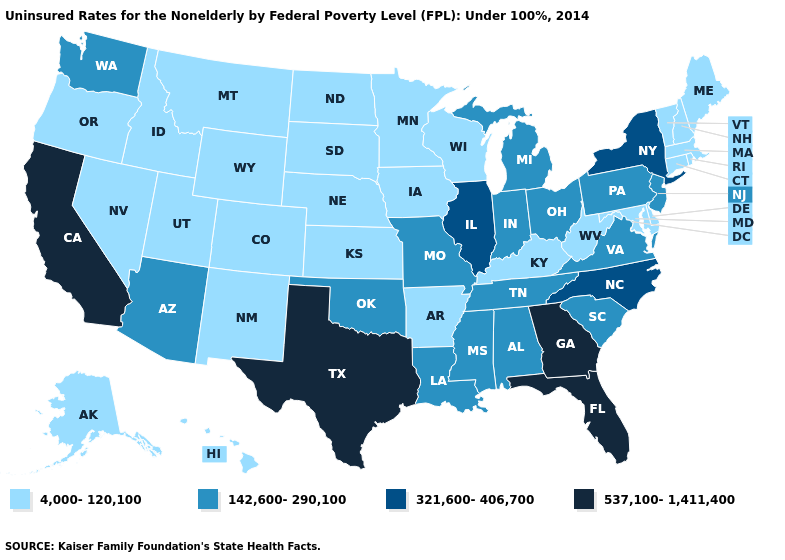Does New Hampshire have the lowest value in the Northeast?
Keep it brief. Yes. Name the states that have a value in the range 142,600-290,100?
Concise answer only. Alabama, Arizona, Indiana, Louisiana, Michigan, Mississippi, Missouri, New Jersey, Ohio, Oklahoma, Pennsylvania, South Carolina, Tennessee, Virginia, Washington. Which states have the lowest value in the South?
Give a very brief answer. Arkansas, Delaware, Kentucky, Maryland, West Virginia. Name the states that have a value in the range 142,600-290,100?
Give a very brief answer. Alabama, Arizona, Indiana, Louisiana, Michigan, Mississippi, Missouri, New Jersey, Ohio, Oklahoma, Pennsylvania, South Carolina, Tennessee, Virginia, Washington. Is the legend a continuous bar?
Be succinct. No. Name the states that have a value in the range 4,000-120,100?
Give a very brief answer. Alaska, Arkansas, Colorado, Connecticut, Delaware, Hawaii, Idaho, Iowa, Kansas, Kentucky, Maine, Maryland, Massachusetts, Minnesota, Montana, Nebraska, Nevada, New Hampshire, New Mexico, North Dakota, Oregon, Rhode Island, South Dakota, Utah, Vermont, West Virginia, Wisconsin, Wyoming. What is the highest value in states that border Indiana?
Quick response, please. 321,600-406,700. Which states hav the highest value in the West?
Keep it brief. California. What is the value of Delaware?
Give a very brief answer. 4,000-120,100. Name the states that have a value in the range 142,600-290,100?
Write a very short answer. Alabama, Arizona, Indiana, Louisiana, Michigan, Mississippi, Missouri, New Jersey, Ohio, Oklahoma, Pennsylvania, South Carolina, Tennessee, Virginia, Washington. What is the value of Washington?
Write a very short answer. 142,600-290,100. How many symbols are there in the legend?
Be succinct. 4. What is the value of New Jersey?
Keep it brief. 142,600-290,100. Name the states that have a value in the range 4,000-120,100?
Short answer required. Alaska, Arkansas, Colorado, Connecticut, Delaware, Hawaii, Idaho, Iowa, Kansas, Kentucky, Maine, Maryland, Massachusetts, Minnesota, Montana, Nebraska, Nevada, New Hampshire, New Mexico, North Dakota, Oregon, Rhode Island, South Dakota, Utah, Vermont, West Virginia, Wisconsin, Wyoming. What is the value of New Jersey?
Be succinct. 142,600-290,100. 